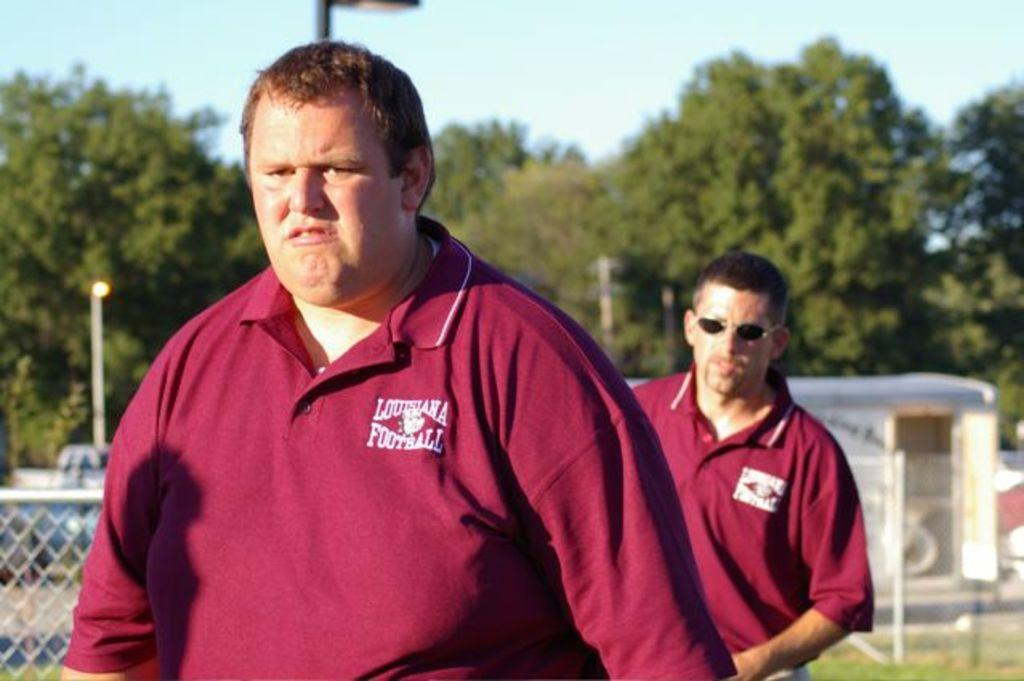<image>
Share a concise interpretation of the image provided. Man wearing a red polo that says Louisiana Football on the field. 